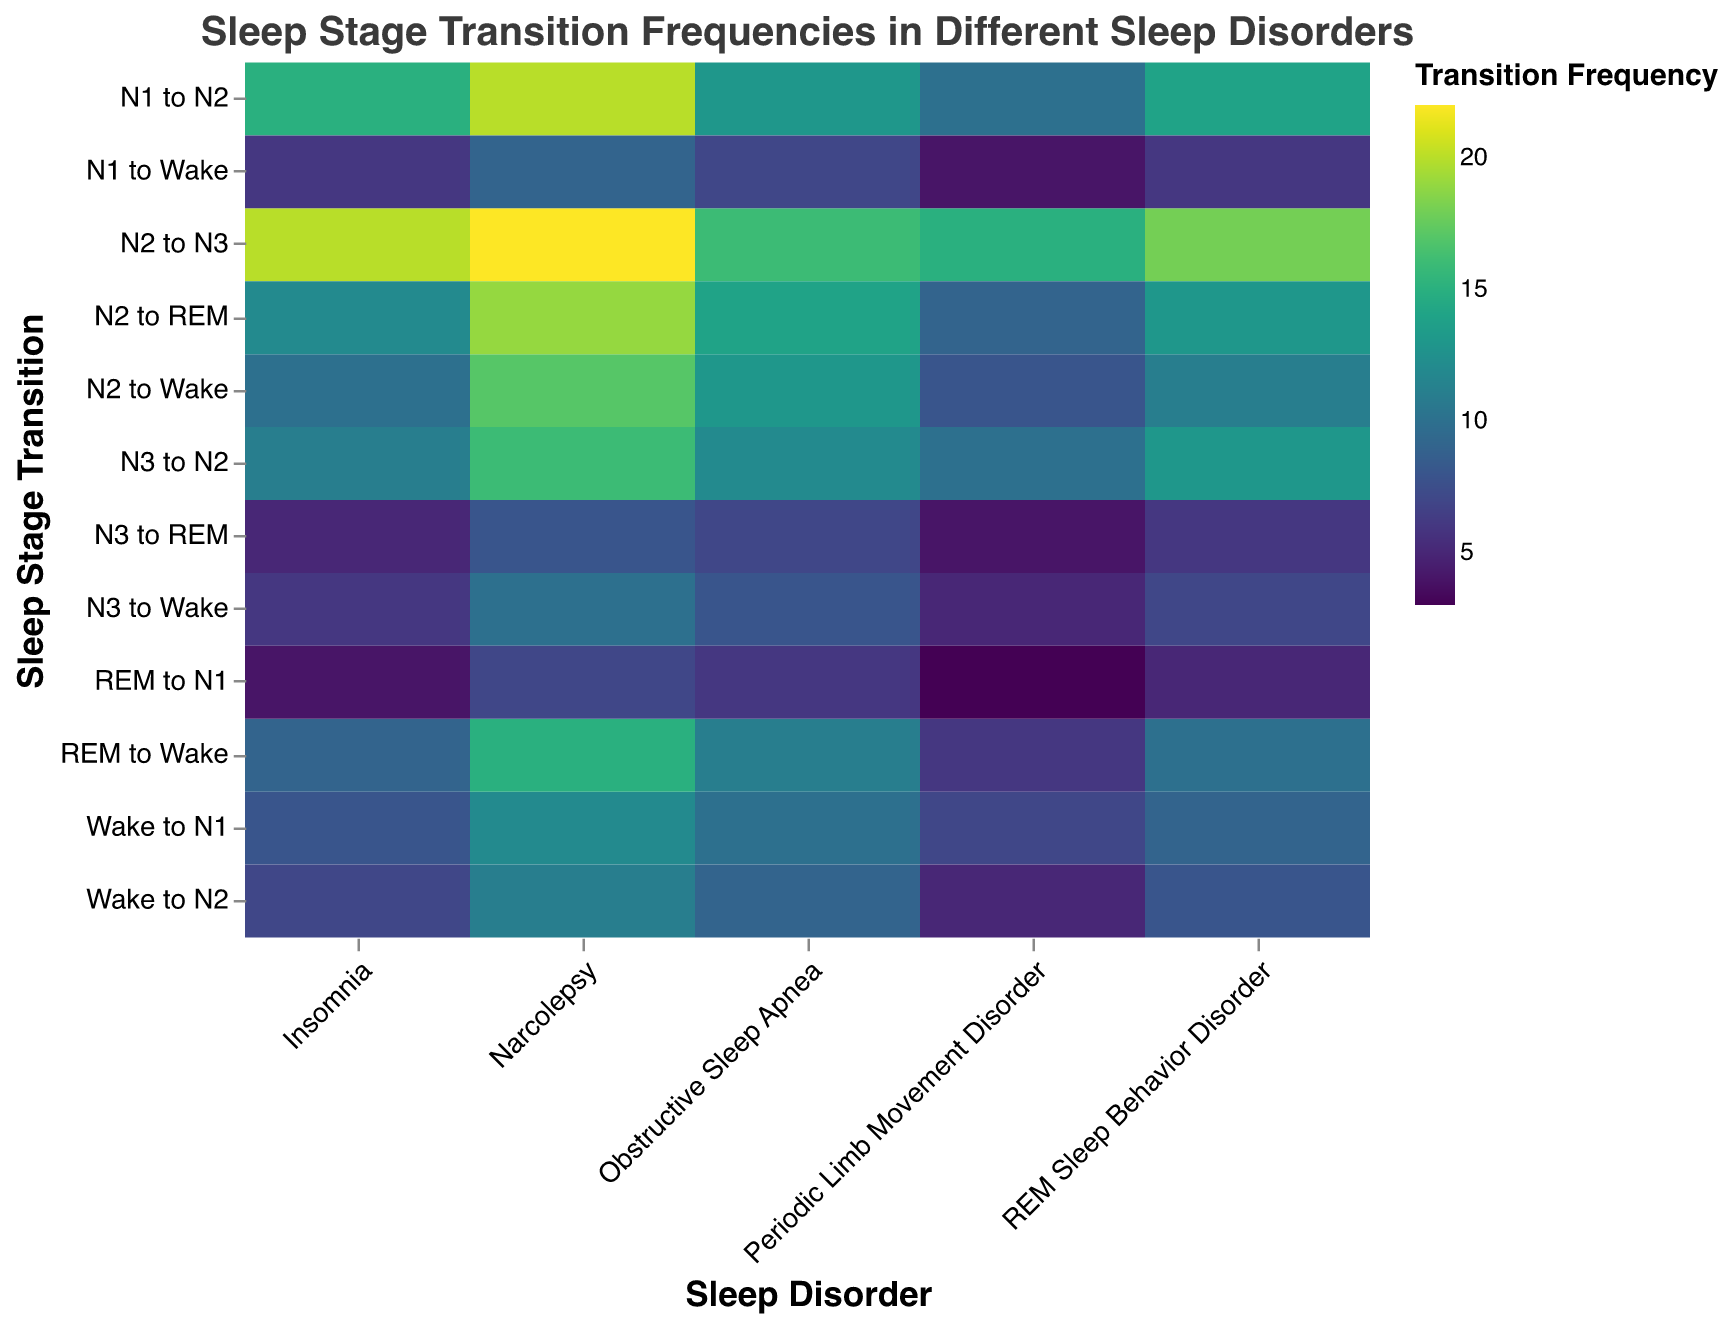What is the title of the figure? The title is located at the top of the figure and usually describes the main topic of the visualized data
Answer: "Sleep Stage Transition Frequencies in Different Sleep Disorders" In which sleep disorder is the transition from N2 to N3 most frequent? Locate the row corresponding to "N2 to N3" and find the column with the highest value in that row
Answer: Narcolepsy Which sleep stage transition in Narcolepsy has the lowest frequency? Look for the lowest value in the Narcolepsy column across all sleep stage transitions
Answer: REM to N1 Which disorder has the highest transition frequency from REM to Wake? Look at the "REM to Wake" row and find the highest value
Answer: Narcolepsy Between Insomnia and Obstructive Sleep Apnea, which one has a higher frequency of transitioning from N3 to REM? Compare the values for "N3 to REM" in the Insomnia and Obstructive Sleep Apnea columns
Answer: Obstructive Sleep Apnea What is the average transition frequency from N1 to N2 across all disorders? Sum the values in the "N1 to N2" row and divide by the number of disorders (5)
Answer: (15 + 13 + 14 + 20 + 10) / 5 = 14.4 What is the difference in transition frequency from N2 to Wake between Insomnia and Periodic Limb Movement Disorder? Subtract the value for Periodic Limb Movement Disorder from the value for Insomnia in the "N2 to Wake" row
Answer: 10 - 8 = 2 Are there any transitions where the frequency is equal across all sleep disorders? Check every row to see if there's any row having the same values across all columns. None in this case.
Answer: No Which is more frequent in Obstructive Sleep Apnea, transitions from N2 to REM or from N1 to Wake? Compare the values in the Obstructive Sleep Apnea column for "N2 to REM" and "N1 to Wake"
Answer: N2 to REM 